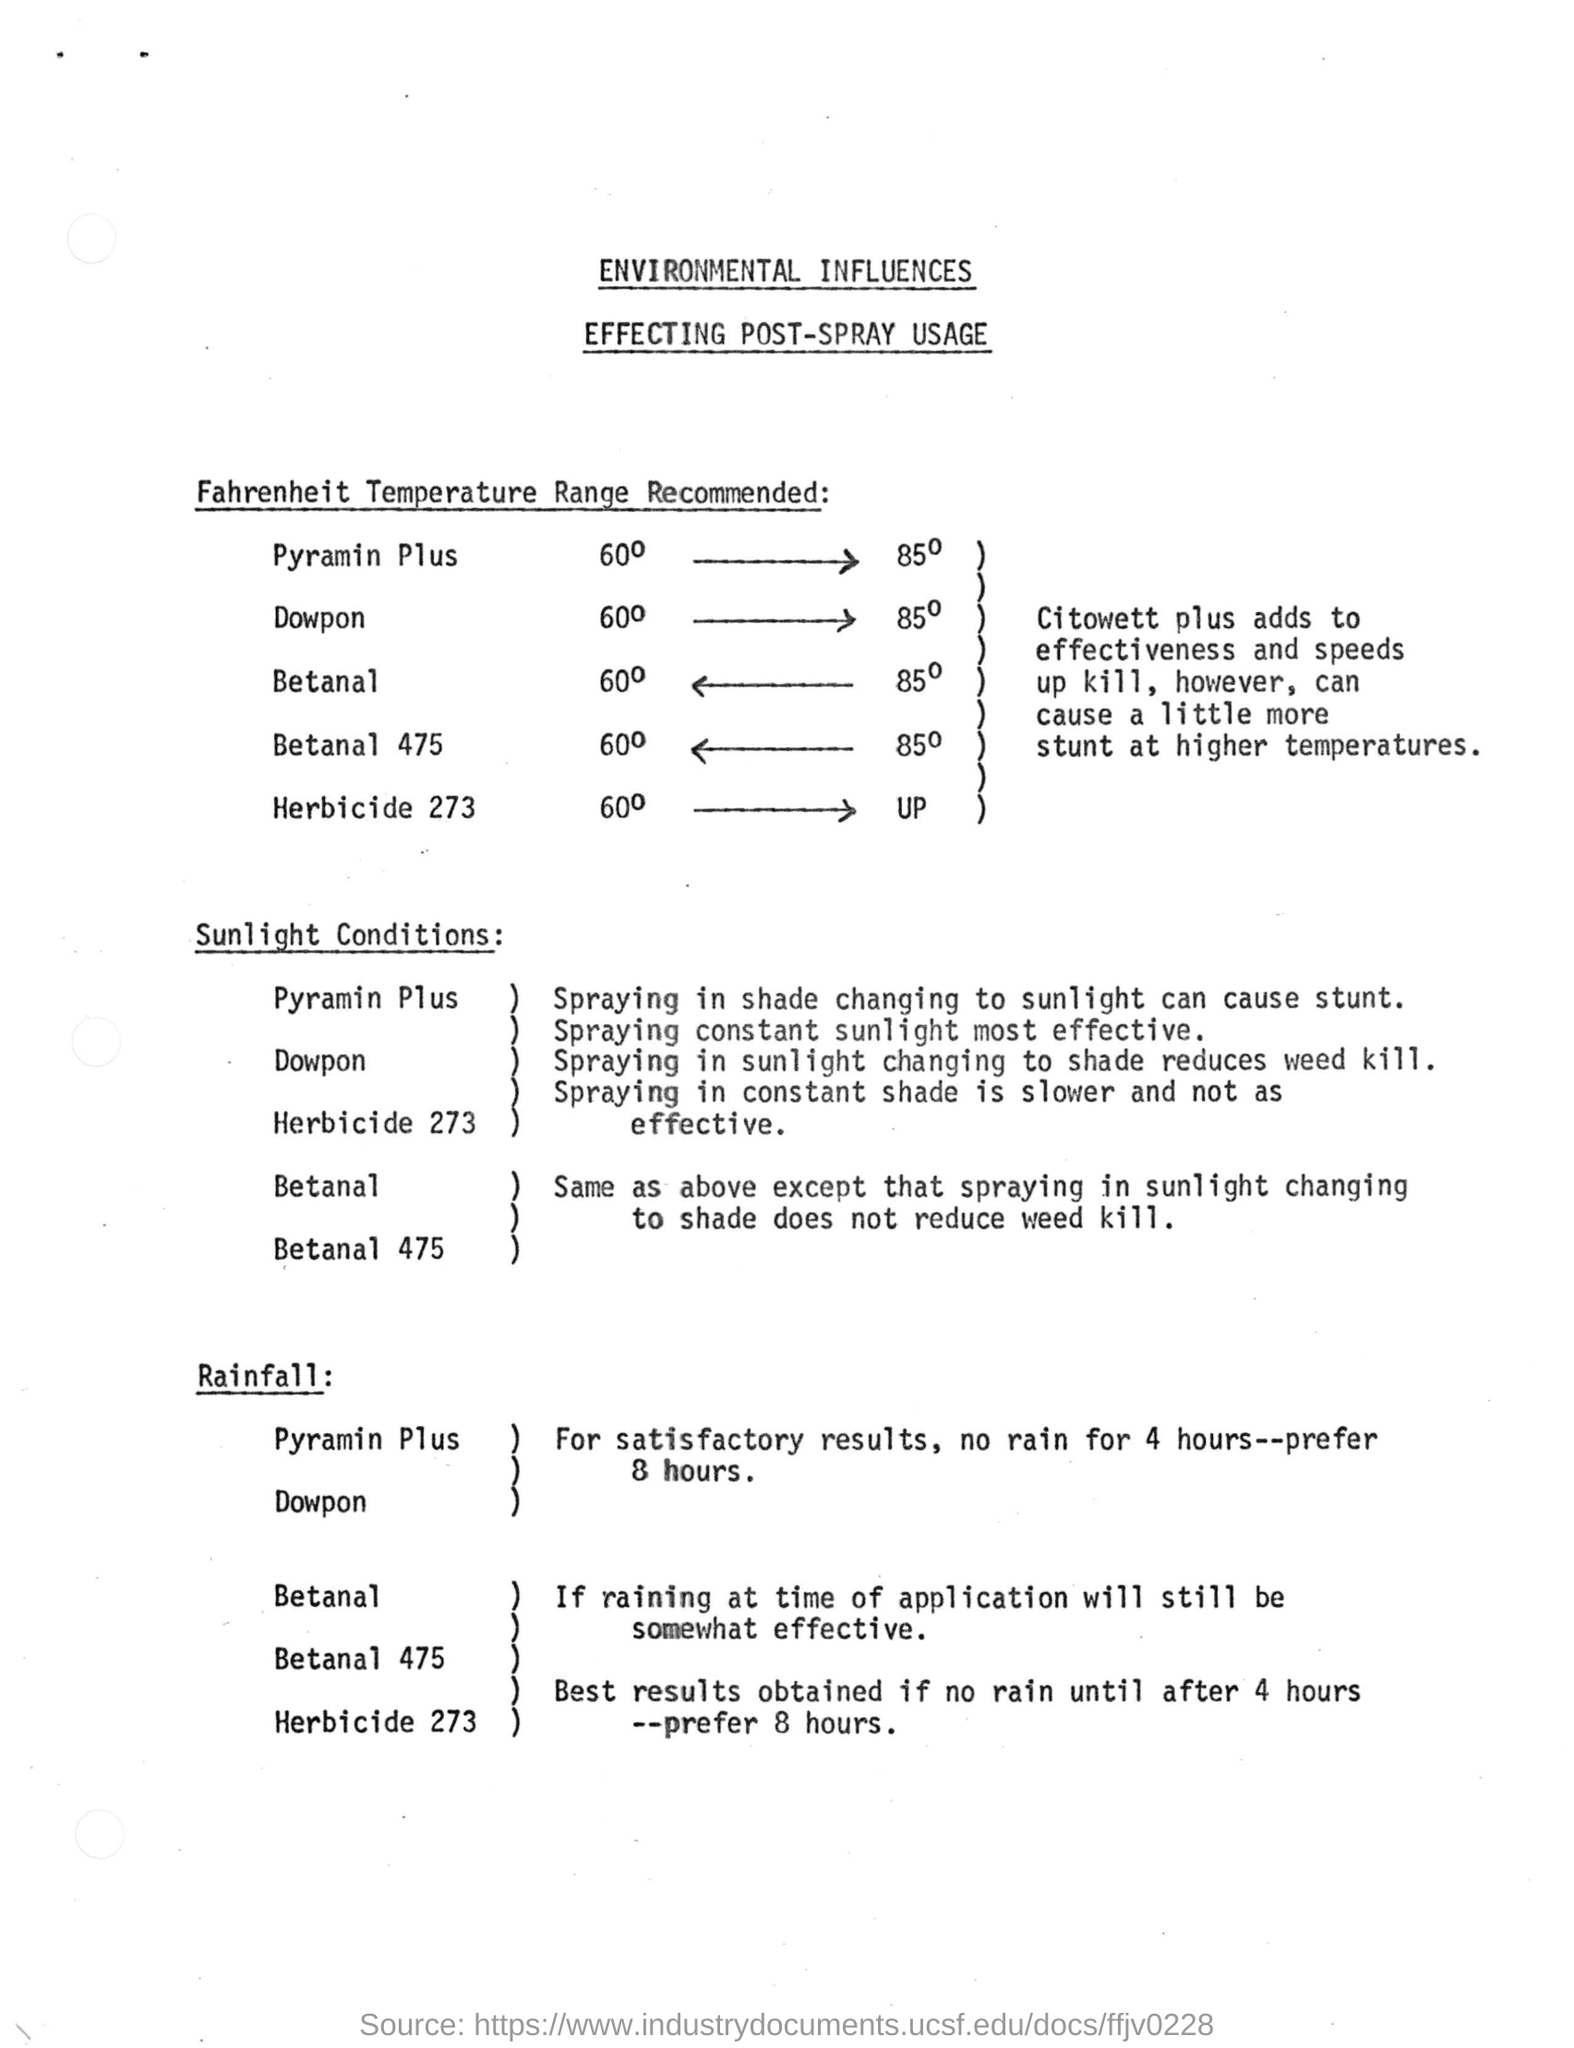Specify some key components in this picture. Citowett Plus enhances the effectiveness and accelerates the killing process, but may cause slightly more stun at higher temperatures. Exposure to sudden changes in light levels, such as spraying in the shade and then moving into direct sunlight, can cause stunting in plants. It is generally slower and less effective to spray in constant shade compared to spraying in areas with direct sunlight. The document is titled "Environmental Influences Affecting Post-Spray Usage. 